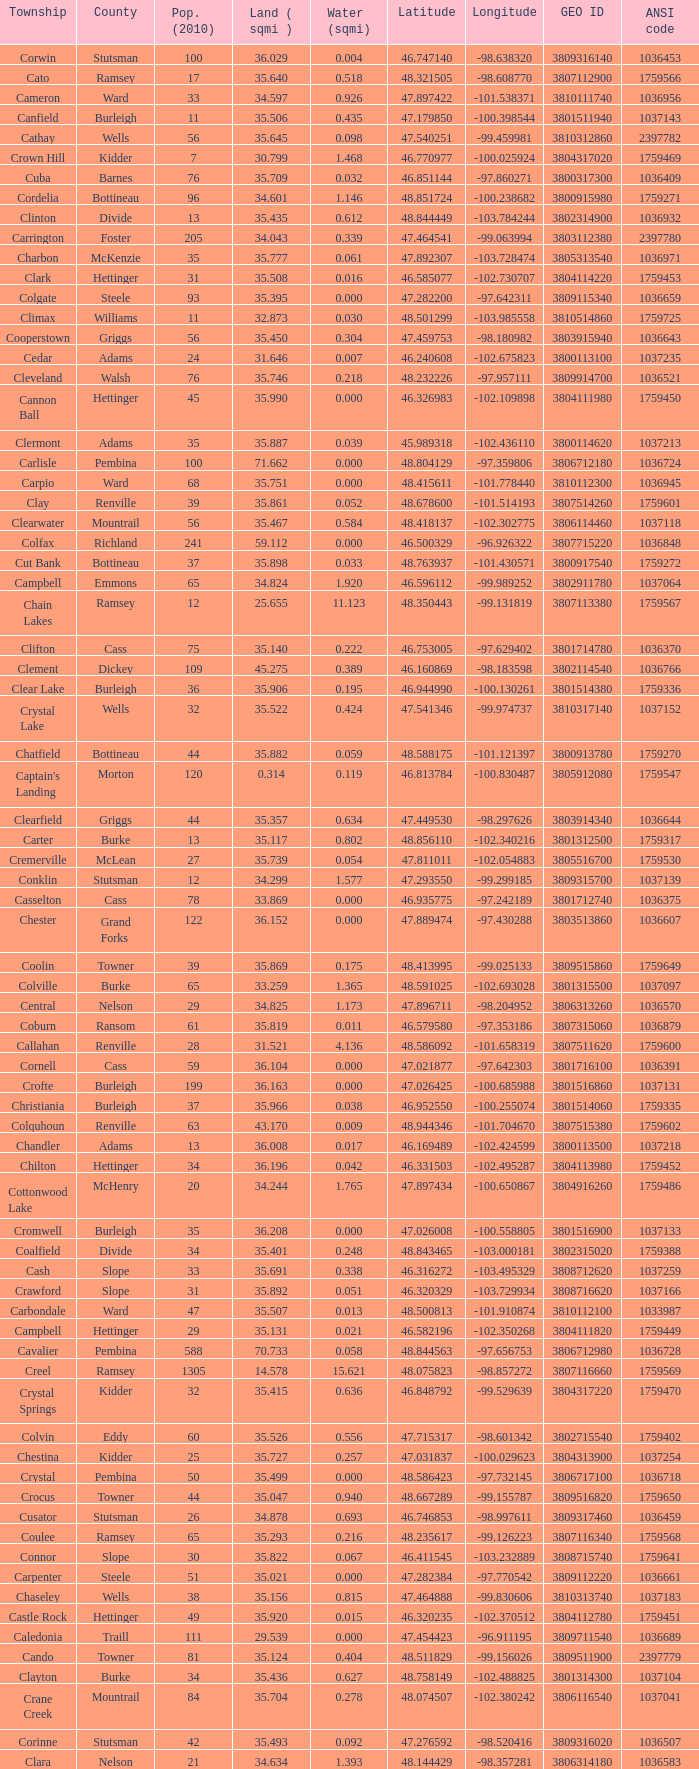What was the township with a geo ID of 3807116660? Creel. 